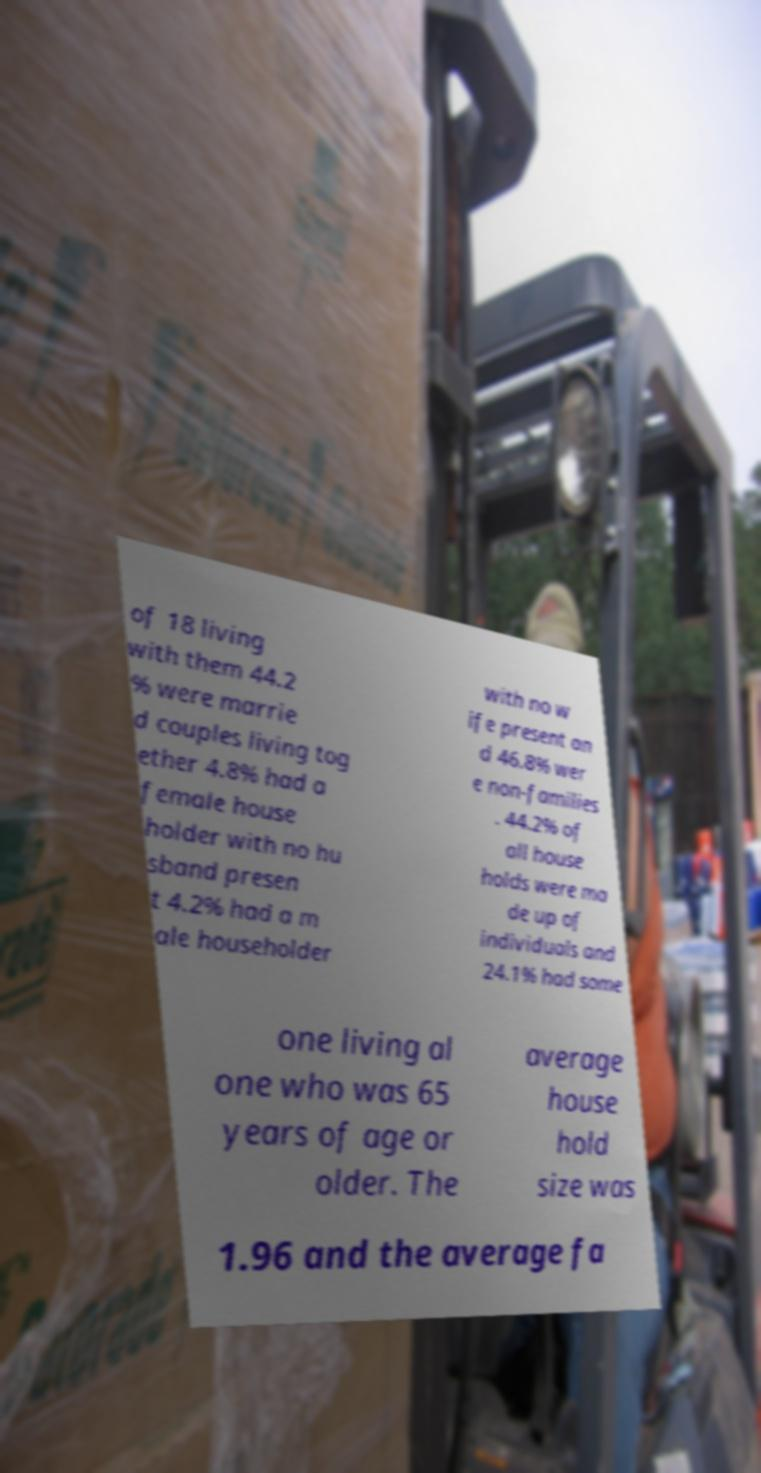What messages or text are displayed in this image? I need them in a readable, typed format. of 18 living with them 44.2 % were marrie d couples living tog ether 4.8% had a female house holder with no hu sband presen t 4.2% had a m ale householder with no w ife present an d 46.8% wer e non-families . 44.2% of all house holds were ma de up of individuals and 24.1% had some one living al one who was 65 years of age or older. The average house hold size was 1.96 and the average fa 